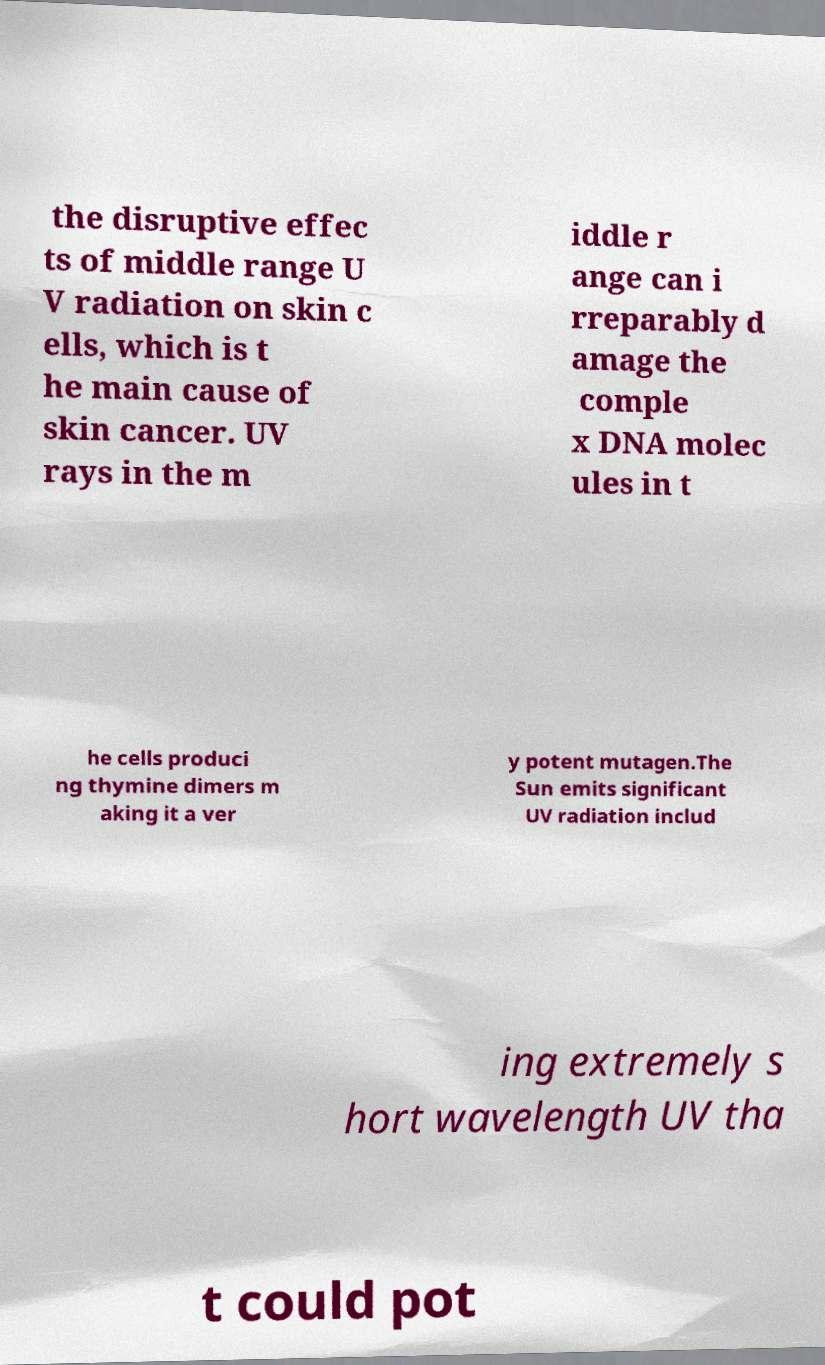There's text embedded in this image that I need extracted. Can you transcribe it verbatim? the disruptive effec ts of middle range U V radiation on skin c ells, which is t he main cause of skin cancer. UV rays in the m iddle r ange can i rreparably d amage the comple x DNA molec ules in t he cells produci ng thymine dimers m aking it a ver y potent mutagen.The Sun emits significant UV radiation includ ing extremely s hort wavelength UV tha t could pot 